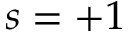Convert formula to latex. <formula><loc_0><loc_0><loc_500><loc_500>s = + 1</formula> 